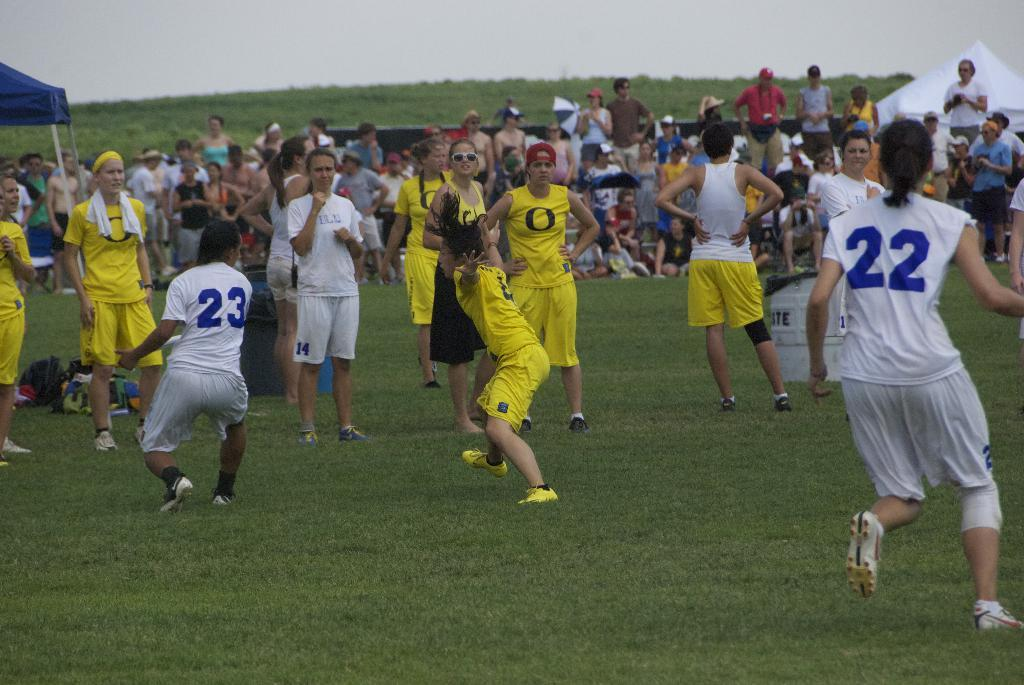Provide a one-sentence caption for the provided image. Blue and white players #22 and #23 are seen on the field against several yellow players with an O an their jerseys. 